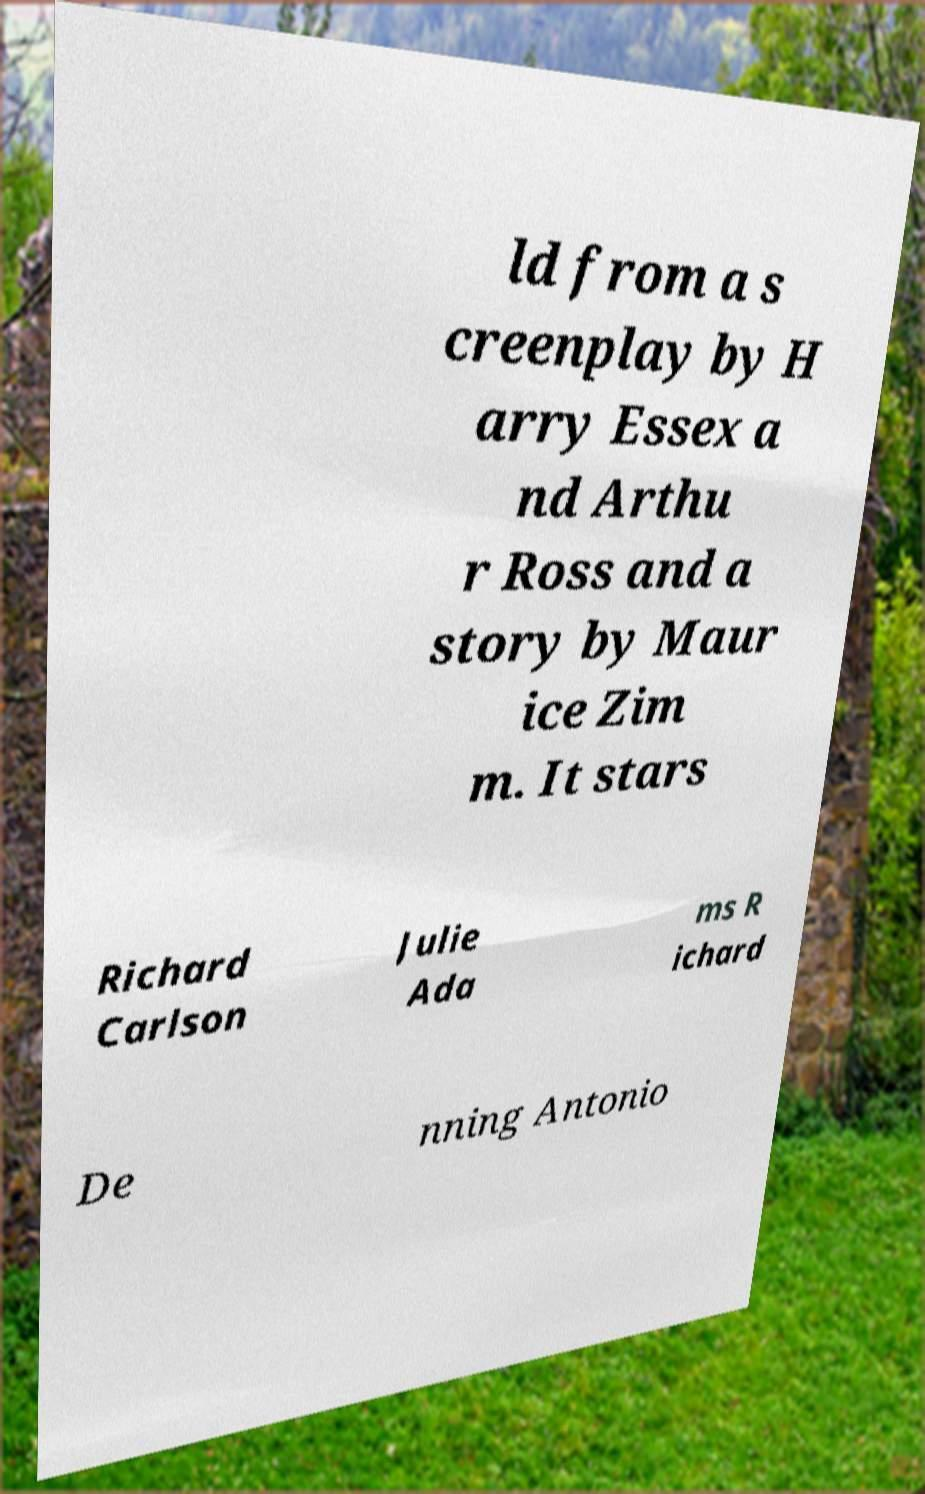I need the written content from this picture converted into text. Can you do that? ld from a s creenplay by H arry Essex a nd Arthu r Ross and a story by Maur ice Zim m. It stars Richard Carlson Julie Ada ms R ichard De nning Antonio 